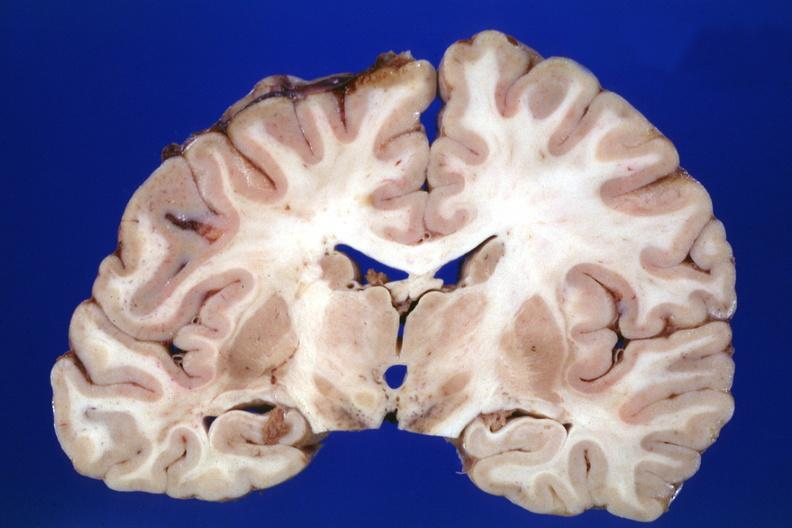what is present?
Answer the question using a single word or phrase. Brain 